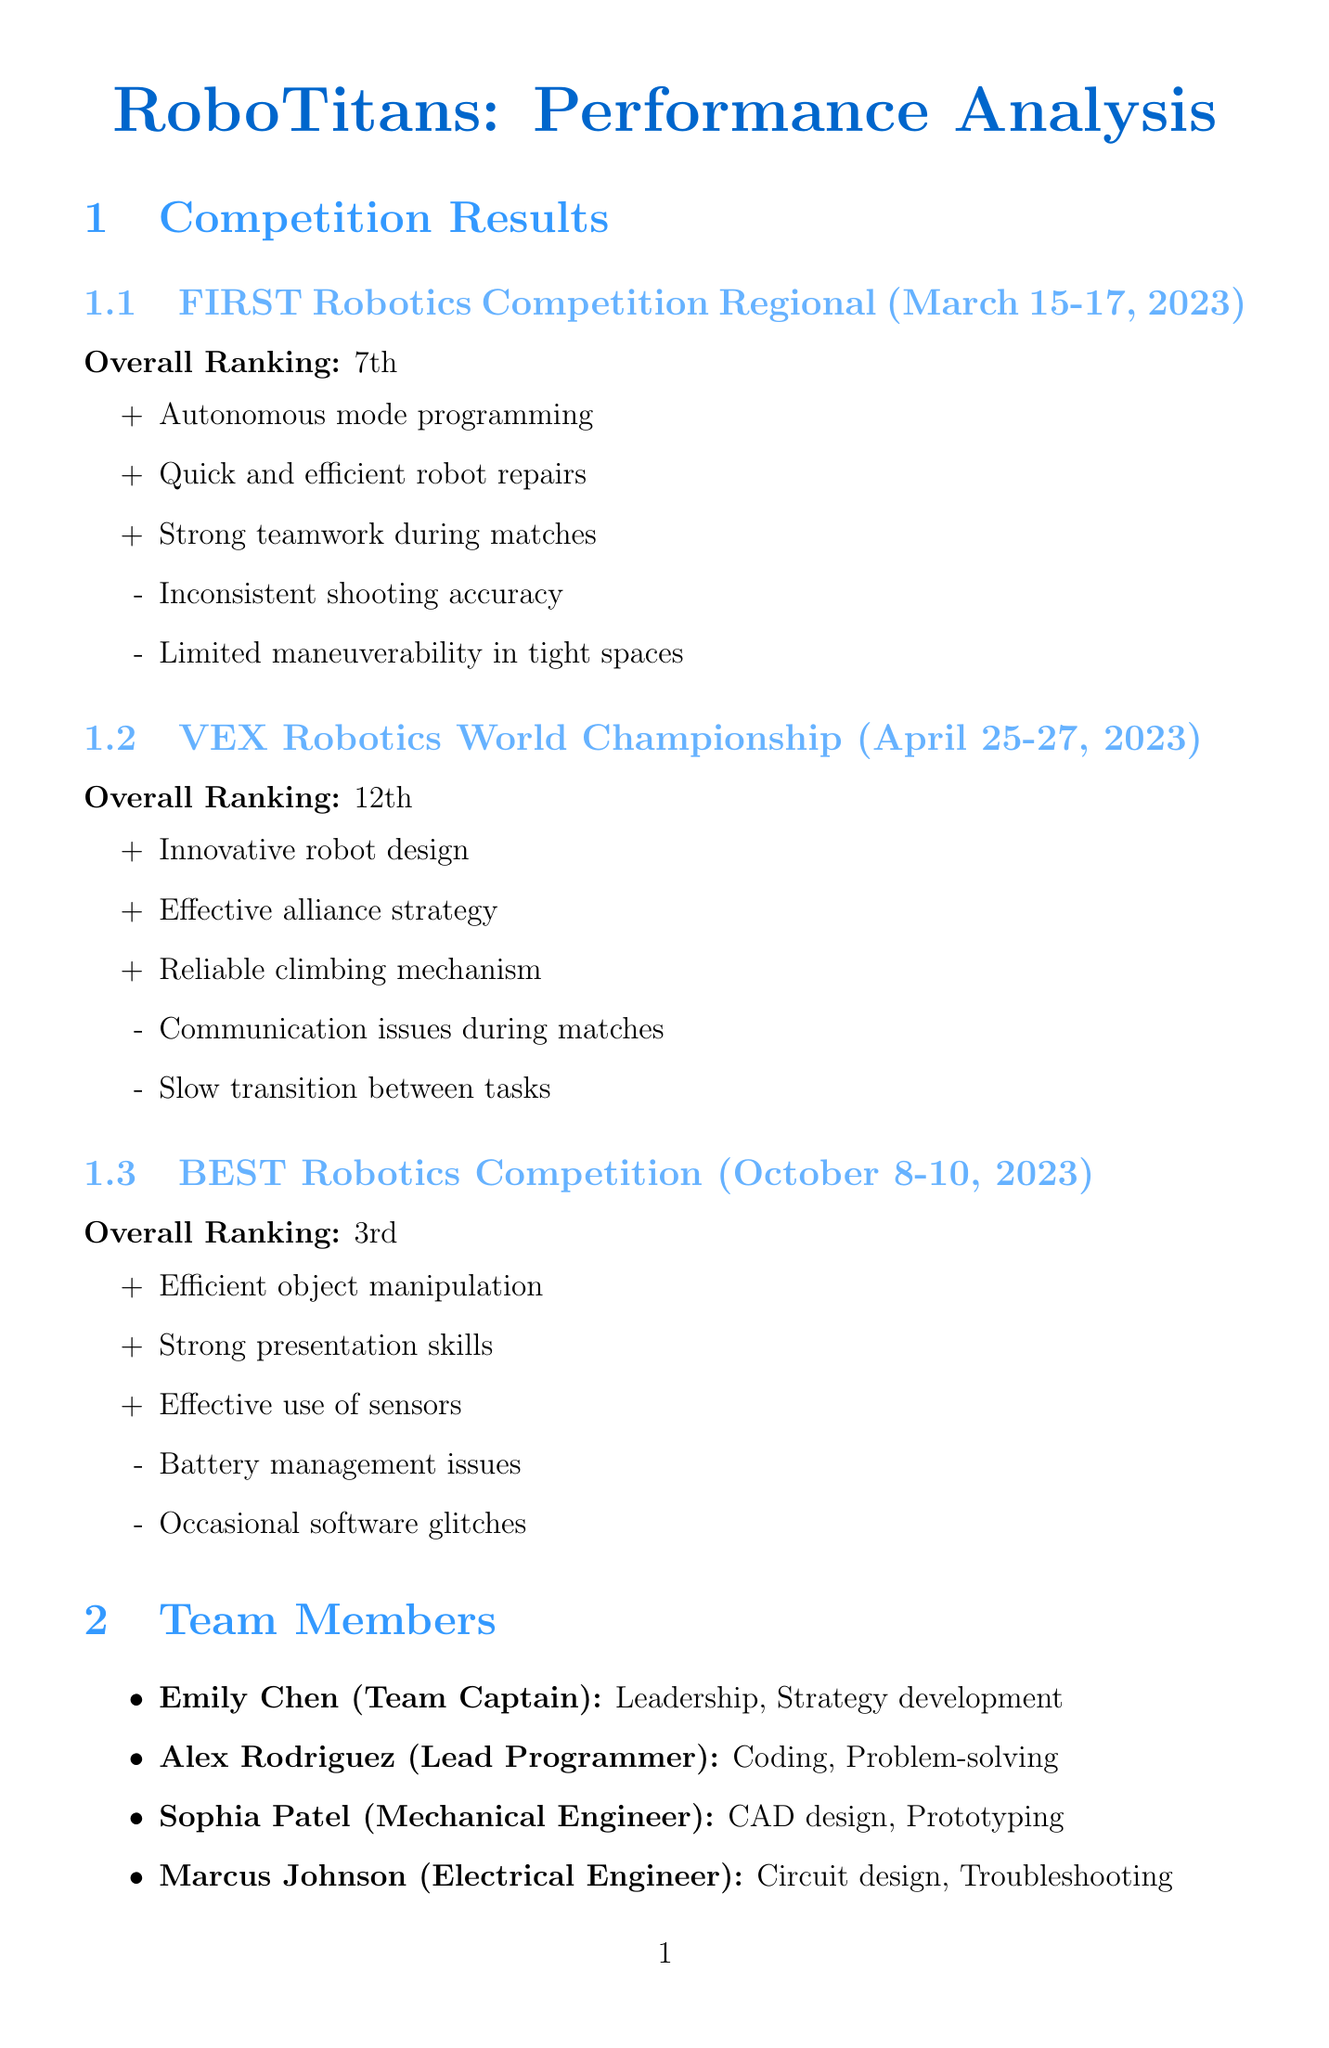What was the overall ranking of RoboTitans in the FIRST Robotics Competition Regional? The overall ranking is listed as 7th in the competition results section.
Answer: 7th What are two strengths of the team during the BEST Robotics Competition? The document lists three strengths for the BEST Robotics Competition, which include efficient object manipulation and strong presentation skills.
Answer: Efficient object manipulation, strong presentation skills What were the weaknesses noted during the VEX Robotics World Championship? The weaknesses are specified in the competition results section for this event: communication issues during matches and slow transition between tasks.
Answer: Communication issues during matches, slow transition between tasks What is one area for improvement in teamwork? The document specifies areas for improvement, and one of them is to develop better communication protocols during matches.
Answer: Develop better communication protocols during matches How has the overall competition ranking trend changed for the team? The trend analysis in the document indicates a movement from 7th to 3rd place overall.
Answer: From 7th to 3rd place What is one key lesson learned from the competitions? The key lessons section mentions that early prototyping is crucial for identifying design flaws.
Answer: Early prototyping is crucial for identifying design flaws Who is the lead programmer on the team? The team members section explicitly mentions Alex Rodriguez as the lead programmer.
Answer: Alex Rodriguez What is one of the future goals for the team? The future goals section outlines that the team aims to achieve a top 3 ranking in the next FIRST Robotics Competition.
Answer: Achieve a top 3 ranking in the next FIRST Robotics Competition 